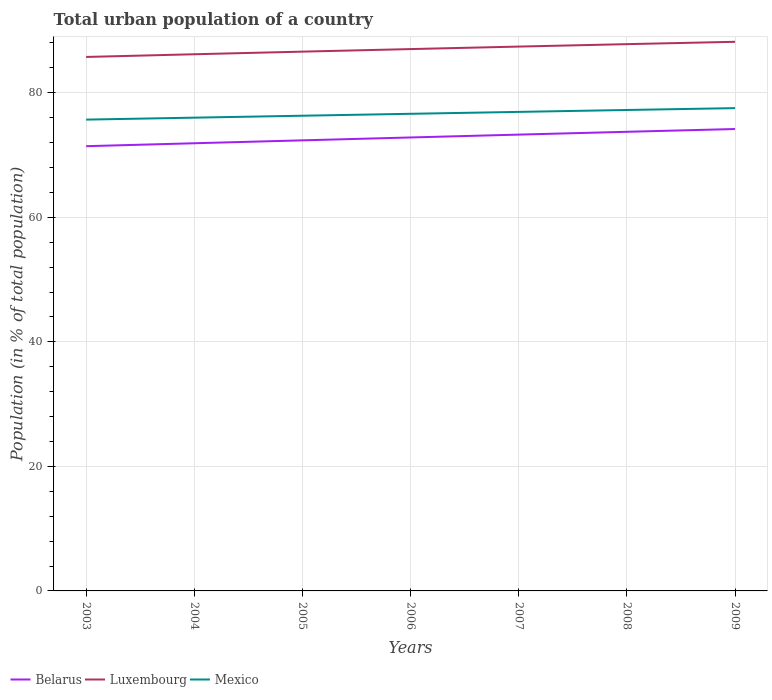Across all years, what is the maximum urban population in Luxembourg?
Offer a terse response. 85.74. What is the total urban population in Belarus in the graph?
Your answer should be very brief. -0.46. What is the difference between the highest and the second highest urban population in Belarus?
Provide a succinct answer. 2.76. What is the difference between the highest and the lowest urban population in Mexico?
Offer a very short reply. 4. Is the urban population in Mexico strictly greater than the urban population in Belarus over the years?
Keep it short and to the point. No. How many years are there in the graph?
Ensure brevity in your answer.  7. What is the difference between two consecutive major ticks on the Y-axis?
Your response must be concise. 20. Does the graph contain any zero values?
Your answer should be very brief. No. Does the graph contain grids?
Ensure brevity in your answer.  Yes. What is the title of the graph?
Provide a succinct answer. Total urban population of a country. Does "Bahrain" appear as one of the legend labels in the graph?
Offer a terse response. No. What is the label or title of the X-axis?
Ensure brevity in your answer.  Years. What is the label or title of the Y-axis?
Your response must be concise. Population (in % of total population). What is the Population (in % of total population) in Belarus in 2003?
Offer a terse response. 71.42. What is the Population (in % of total population) of Luxembourg in 2003?
Provide a succinct answer. 85.74. What is the Population (in % of total population) in Mexico in 2003?
Provide a succinct answer. 75.68. What is the Population (in % of total population) of Belarus in 2004?
Keep it short and to the point. 71.89. What is the Population (in % of total population) of Luxembourg in 2004?
Provide a succinct answer. 86.18. What is the Population (in % of total population) in Mexico in 2004?
Provide a short and direct response. 76. What is the Population (in % of total population) in Belarus in 2005?
Give a very brief answer. 72.35. What is the Population (in % of total population) in Luxembourg in 2005?
Your response must be concise. 86.6. What is the Population (in % of total population) in Mexico in 2005?
Give a very brief answer. 76.31. What is the Population (in % of total population) in Belarus in 2006?
Keep it short and to the point. 72.82. What is the Population (in % of total population) of Luxembourg in 2006?
Offer a very short reply. 87.01. What is the Population (in % of total population) in Mexico in 2006?
Give a very brief answer. 76.62. What is the Population (in % of total population) in Belarus in 2007?
Your answer should be compact. 73.27. What is the Population (in % of total population) of Luxembourg in 2007?
Give a very brief answer. 87.41. What is the Population (in % of total population) in Mexico in 2007?
Ensure brevity in your answer.  76.92. What is the Population (in % of total population) in Belarus in 2008?
Keep it short and to the point. 73.73. What is the Population (in % of total population) of Luxembourg in 2008?
Offer a very short reply. 87.8. What is the Population (in % of total population) of Mexico in 2008?
Keep it short and to the point. 77.23. What is the Population (in % of total population) in Belarus in 2009?
Your answer should be compact. 74.17. What is the Population (in % of total population) of Luxembourg in 2009?
Offer a terse response. 88.18. What is the Population (in % of total population) of Mexico in 2009?
Keep it short and to the point. 77.53. Across all years, what is the maximum Population (in % of total population) of Belarus?
Give a very brief answer. 74.17. Across all years, what is the maximum Population (in % of total population) of Luxembourg?
Make the answer very short. 88.18. Across all years, what is the maximum Population (in % of total population) of Mexico?
Give a very brief answer. 77.53. Across all years, what is the minimum Population (in % of total population) of Belarus?
Offer a terse response. 71.42. Across all years, what is the minimum Population (in % of total population) of Luxembourg?
Your answer should be very brief. 85.74. Across all years, what is the minimum Population (in % of total population) of Mexico?
Your answer should be compact. 75.68. What is the total Population (in % of total population) in Belarus in the graph?
Your response must be concise. 509.64. What is the total Population (in % of total population) of Luxembourg in the graph?
Make the answer very short. 608.91. What is the total Population (in % of total population) in Mexico in the graph?
Offer a terse response. 536.28. What is the difference between the Population (in % of total population) of Belarus in 2003 and that in 2004?
Offer a terse response. -0.47. What is the difference between the Population (in % of total population) in Luxembourg in 2003 and that in 2004?
Offer a very short reply. -0.43. What is the difference between the Population (in % of total population) in Mexico in 2003 and that in 2004?
Keep it short and to the point. -0.32. What is the difference between the Population (in % of total population) in Belarus in 2003 and that in 2005?
Offer a very short reply. -0.94. What is the difference between the Population (in % of total population) in Luxembourg in 2003 and that in 2005?
Provide a succinct answer. -0.85. What is the difference between the Population (in % of total population) in Mexico in 2003 and that in 2005?
Provide a succinct answer. -0.63. What is the difference between the Population (in % of total population) in Belarus in 2003 and that in 2006?
Provide a succinct answer. -1.4. What is the difference between the Population (in % of total population) in Luxembourg in 2003 and that in 2006?
Offer a very short reply. -1.27. What is the difference between the Population (in % of total population) in Mexico in 2003 and that in 2006?
Offer a very short reply. -0.94. What is the difference between the Population (in % of total population) of Belarus in 2003 and that in 2007?
Provide a short and direct response. -1.86. What is the difference between the Population (in % of total population) in Luxembourg in 2003 and that in 2007?
Offer a terse response. -1.67. What is the difference between the Population (in % of total population) in Mexico in 2003 and that in 2007?
Provide a succinct answer. -1.24. What is the difference between the Population (in % of total population) of Belarus in 2003 and that in 2008?
Offer a terse response. -2.31. What is the difference between the Population (in % of total population) of Luxembourg in 2003 and that in 2008?
Your answer should be compact. -2.06. What is the difference between the Population (in % of total population) of Mexico in 2003 and that in 2008?
Keep it short and to the point. -1.54. What is the difference between the Population (in % of total population) in Belarus in 2003 and that in 2009?
Provide a short and direct response. -2.76. What is the difference between the Population (in % of total population) in Luxembourg in 2003 and that in 2009?
Offer a terse response. -2.44. What is the difference between the Population (in % of total population) of Mexico in 2003 and that in 2009?
Give a very brief answer. -1.84. What is the difference between the Population (in % of total population) in Belarus in 2004 and that in 2005?
Ensure brevity in your answer.  -0.47. What is the difference between the Population (in % of total population) of Luxembourg in 2004 and that in 2005?
Provide a short and direct response. -0.42. What is the difference between the Population (in % of total population) in Mexico in 2004 and that in 2005?
Offer a terse response. -0.31. What is the difference between the Population (in % of total population) of Belarus in 2004 and that in 2006?
Give a very brief answer. -0.93. What is the difference between the Population (in % of total population) of Luxembourg in 2004 and that in 2006?
Provide a succinct answer. -0.83. What is the difference between the Population (in % of total population) in Mexico in 2004 and that in 2006?
Your answer should be compact. -0.62. What is the difference between the Population (in % of total population) in Belarus in 2004 and that in 2007?
Your response must be concise. -1.39. What is the difference between the Population (in % of total population) in Luxembourg in 2004 and that in 2007?
Provide a succinct answer. -1.23. What is the difference between the Population (in % of total population) of Mexico in 2004 and that in 2007?
Provide a succinct answer. -0.93. What is the difference between the Population (in % of total population) of Belarus in 2004 and that in 2008?
Give a very brief answer. -1.84. What is the difference between the Population (in % of total population) in Luxembourg in 2004 and that in 2008?
Your answer should be compact. -1.62. What is the difference between the Population (in % of total population) of Mexico in 2004 and that in 2008?
Make the answer very short. -1.23. What is the difference between the Population (in % of total population) in Belarus in 2004 and that in 2009?
Keep it short and to the point. -2.29. What is the difference between the Population (in % of total population) of Luxembourg in 2004 and that in 2009?
Make the answer very short. -2. What is the difference between the Population (in % of total population) of Mexico in 2004 and that in 2009?
Your answer should be compact. -1.53. What is the difference between the Population (in % of total population) of Belarus in 2005 and that in 2006?
Your answer should be very brief. -0.46. What is the difference between the Population (in % of total population) in Luxembourg in 2005 and that in 2006?
Your answer should be compact. -0.41. What is the difference between the Population (in % of total population) of Mexico in 2005 and that in 2006?
Your response must be concise. -0.31. What is the difference between the Population (in % of total population) of Belarus in 2005 and that in 2007?
Your answer should be very brief. -0.92. What is the difference between the Population (in % of total population) of Luxembourg in 2005 and that in 2007?
Give a very brief answer. -0.81. What is the difference between the Population (in % of total population) in Mexico in 2005 and that in 2007?
Offer a terse response. -0.61. What is the difference between the Population (in % of total population) of Belarus in 2005 and that in 2008?
Offer a terse response. -1.37. What is the difference between the Population (in % of total population) in Luxembourg in 2005 and that in 2008?
Make the answer very short. -1.2. What is the difference between the Population (in % of total population) in Mexico in 2005 and that in 2008?
Provide a short and direct response. -0.92. What is the difference between the Population (in % of total population) of Belarus in 2005 and that in 2009?
Make the answer very short. -1.82. What is the difference between the Population (in % of total population) in Luxembourg in 2005 and that in 2009?
Give a very brief answer. -1.58. What is the difference between the Population (in % of total population) of Mexico in 2005 and that in 2009?
Your answer should be compact. -1.22. What is the difference between the Population (in % of total population) of Belarus in 2006 and that in 2007?
Offer a very short reply. -0.46. What is the difference between the Population (in % of total population) of Luxembourg in 2006 and that in 2007?
Keep it short and to the point. -0.4. What is the difference between the Population (in % of total population) in Mexico in 2006 and that in 2007?
Give a very brief answer. -0.31. What is the difference between the Population (in % of total population) of Belarus in 2006 and that in 2008?
Your answer should be compact. -0.91. What is the difference between the Population (in % of total population) of Luxembourg in 2006 and that in 2008?
Provide a succinct answer. -0.79. What is the difference between the Population (in % of total population) of Mexico in 2006 and that in 2008?
Offer a very short reply. -0.61. What is the difference between the Population (in % of total population) of Belarus in 2006 and that in 2009?
Offer a very short reply. -1.36. What is the difference between the Population (in % of total population) of Luxembourg in 2006 and that in 2009?
Your answer should be very brief. -1.17. What is the difference between the Population (in % of total population) of Mexico in 2006 and that in 2009?
Offer a very short reply. -0.91. What is the difference between the Population (in % of total population) of Belarus in 2007 and that in 2008?
Give a very brief answer. -0.45. What is the difference between the Population (in % of total population) of Luxembourg in 2007 and that in 2008?
Your response must be concise. -0.39. What is the difference between the Population (in % of total population) of Mexico in 2007 and that in 2008?
Give a very brief answer. -0.3. What is the difference between the Population (in % of total population) of Belarus in 2007 and that in 2009?
Provide a short and direct response. -0.9. What is the difference between the Population (in % of total population) of Luxembourg in 2007 and that in 2009?
Keep it short and to the point. -0.77. What is the difference between the Population (in % of total population) in Mexico in 2007 and that in 2009?
Give a very brief answer. -0.6. What is the difference between the Population (in % of total population) of Belarus in 2008 and that in 2009?
Your response must be concise. -0.45. What is the difference between the Population (in % of total population) of Luxembourg in 2008 and that in 2009?
Give a very brief answer. -0.38. What is the difference between the Population (in % of total population) in Belarus in 2003 and the Population (in % of total population) in Luxembourg in 2004?
Keep it short and to the point. -14.76. What is the difference between the Population (in % of total population) in Belarus in 2003 and the Population (in % of total population) in Mexico in 2004?
Your response must be concise. -4.58. What is the difference between the Population (in % of total population) in Luxembourg in 2003 and the Population (in % of total population) in Mexico in 2004?
Provide a short and direct response. 9.75. What is the difference between the Population (in % of total population) in Belarus in 2003 and the Population (in % of total population) in Luxembourg in 2005?
Provide a succinct answer. -15.18. What is the difference between the Population (in % of total population) of Belarus in 2003 and the Population (in % of total population) of Mexico in 2005?
Make the answer very short. -4.89. What is the difference between the Population (in % of total population) in Luxembourg in 2003 and the Population (in % of total population) in Mexico in 2005?
Offer a terse response. 9.44. What is the difference between the Population (in % of total population) of Belarus in 2003 and the Population (in % of total population) of Luxembourg in 2006?
Make the answer very short. -15.59. What is the difference between the Population (in % of total population) in Belarus in 2003 and the Population (in % of total population) in Mexico in 2006?
Ensure brevity in your answer.  -5.2. What is the difference between the Population (in % of total population) of Luxembourg in 2003 and the Population (in % of total population) of Mexico in 2006?
Give a very brief answer. 9.13. What is the difference between the Population (in % of total population) in Belarus in 2003 and the Population (in % of total population) in Luxembourg in 2007?
Provide a short and direct response. -15.99. What is the difference between the Population (in % of total population) of Belarus in 2003 and the Population (in % of total population) of Mexico in 2007?
Provide a succinct answer. -5.51. What is the difference between the Population (in % of total population) in Luxembourg in 2003 and the Population (in % of total population) in Mexico in 2007?
Make the answer very short. 8.82. What is the difference between the Population (in % of total population) in Belarus in 2003 and the Population (in % of total population) in Luxembourg in 2008?
Offer a terse response. -16.39. What is the difference between the Population (in % of total population) in Belarus in 2003 and the Population (in % of total population) in Mexico in 2008?
Provide a short and direct response. -5.81. What is the difference between the Population (in % of total population) of Luxembourg in 2003 and the Population (in % of total population) of Mexico in 2008?
Offer a very short reply. 8.52. What is the difference between the Population (in % of total population) of Belarus in 2003 and the Population (in % of total population) of Luxembourg in 2009?
Your response must be concise. -16.76. What is the difference between the Population (in % of total population) of Belarus in 2003 and the Population (in % of total population) of Mexico in 2009?
Provide a succinct answer. -6.11. What is the difference between the Population (in % of total population) of Luxembourg in 2003 and the Population (in % of total population) of Mexico in 2009?
Give a very brief answer. 8.22. What is the difference between the Population (in % of total population) in Belarus in 2004 and the Population (in % of total population) in Luxembourg in 2005?
Give a very brief answer. -14.71. What is the difference between the Population (in % of total population) of Belarus in 2004 and the Population (in % of total population) of Mexico in 2005?
Your answer should be compact. -4.42. What is the difference between the Population (in % of total population) in Luxembourg in 2004 and the Population (in % of total population) in Mexico in 2005?
Ensure brevity in your answer.  9.87. What is the difference between the Population (in % of total population) of Belarus in 2004 and the Population (in % of total population) of Luxembourg in 2006?
Your answer should be very brief. -15.12. What is the difference between the Population (in % of total population) in Belarus in 2004 and the Population (in % of total population) in Mexico in 2006?
Provide a succinct answer. -4.73. What is the difference between the Population (in % of total population) of Luxembourg in 2004 and the Population (in % of total population) of Mexico in 2006?
Offer a terse response. 9.56. What is the difference between the Population (in % of total population) in Belarus in 2004 and the Population (in % of total population) in Luxembourg in 2007?
Ensure brevity in your answer.  -15.52. What is the difference between the Population (in % of total population) in Belarus in 2004 and the Population (in % of total population) in Mexico in 2007?
Your answer should be compact. -5.04. What is the difference between the Population (in % of total population) of Luxembourg in 2004 and the Population (in % of total population) of Mexico in 2007?
Offer a terse response. 9.25. What is the difference between the Population (in % of total population) in Belarus in 2004 and the Population (in % of total population) in Luxembourg in 2008?
Offer a very short reply. -15.91. What is the difference between the Population (in % of total population) in Belarus in 2004 and the Population (in % of total population) in Mexico in 2008?
Your answer should be compact. -5.34. What is the difference between the Population (in % of total population) in Luxembourg in 2004 and the Population (in % of total population) in Mexico in 2008?
Offer a terse response. 8.95. What is the difference between the Population (in % of total population) of Belarus in 2004 and the Population (in % of total population) of Luxembourg in 2009?
Ensure brevity in your answer.  -16.29. What is the difference between the Population (in % of total population) of Belarus in 2004 and the Population (in % of total population) of Mexico in 2009?
Your response must be concise. -5.64. What is the difference between the Population (in % of total population) in Luxembourg in 2004 and the Population (in % of total population) in Mexico in 2009?
Give a very brief answer. 8.65. What is the difference between the Population (in % of total population) in Belarus in 2005 and the Population (in % of total population) in Luxembourg in 2006?
Your answer should be very brief. -14.65. What is the difference between the Population (in % of total population) of Belarus in 2005 and the Population (in % of total population) of Mexico in 2006?
Your answer should be compact. -4.26. What is the difference between the Population (in % of total population) in Luxembourg in 2005 and the Population (in % of total population) in Mexico in 2006?
Your answer should be compact. 9.98. What is the difference between the Population (in % of total population) in Belarus in 2005 and the Population (in % of total population) in Luxembourg in 2007?
Provide a short and direct response. -15.05. What is the difference between the Population (in % of total population) of Belarus in 2005 and the Population (in % of total population) of Mexico in 2007?
Your answer should be very brief. -4.57. What is the difference between the Population (in % of total population) of Luxembourg in 2005 and the Population (in % of total population) of Mexico in 2007?
Give a very brief answer. 9.68. What is the difference between the Population (in % of total population) of Belarus in 2005 and the Population (in % of total population) of Luxembourg in 2008?
Your answer should be compact. -15.45. What is the difference between the Population (in % of total population) in Belarus in 2005 and the Population (in % of total population) in Mexico in 2008?
Your answer should be very brief. -4.87. What is the difference between the Population (in % of total population) in Luxembourg in 2005 and the Population (in % of total population) in Mexico in 2008?
Provide a succinct answer. 9.37. What is the difference between the Population (in % of total population) of Belarus in 2005 and the Population (in % of total population) of Luxembourg in 2009?
Your response must be concise. -15.82. What is the difference between the Population (in % of total population) of Belarus in 2005 and the Population (in % of total population) of Mexico in 2009?
Keep it short and to the point. -5.17. What is the difference between the Population (in % of total population) of Luxembourg in 2005 and the Population (in % of total population) of Mexico in 2009?
Ensure brevity in your answer.  9.07. What is the difference between the Population (in % of total population) of Belarus in 2006 and the Population (in % of total population) of Luxembourg in 2007?
Your answer should be very brief. -14.59. What is the difference between the Population (in % of total population) in Belarus in 2006 and the Population (in % of total population) in Mexico in 2007?
Make the answer very short. -4.11. What is the difference between the Population (in % of total population) of Luxembourg in 2006 and the Population (in % of total population) of Mexico in 2007?
Your answer should be compact. 10.09. What is the difference between the Population (in % of total population) of Belarus in 2006 and the Population (in % of total population) of Luxembourg in 2008?
Your response must be concise. -14.98. What is the difference between the Population (in % of total population) in Belarus in 2006 and the Population (in % of total population) in Mexico in 2008?
Keep it short and to the point. -4.41. What is the difference between the Population (in % of total population) of Luxembourg in 2006 and the Population (in % of total population) of Mexico in 2008?
Keep it short and to the point. 9.78. What is the difference between the Population (in % of total population) of Belarus in 2006 and the Population (in % of total population) of Luxembourg in 2009?
Your answer should be compact. -15.36. What is the difference between the Population (in % of total population) in Belarus in 2006 and the Population (in % of total population) in Mexico in 2009?
Provide a succinct answer. -4.71. What is the difference between the Population (in % of total population) of Luxembourg in 2006 and the Population (in % of total population) of Mexico in 2009?
Give a very brief answer. 9.48. What is the difference between the Population (in % of total population) of Belarus in 2007 and the Population (in % of total population) of Luxembourg in 2008?
Ensure brevity in your answer.  -14.53. What is the difference between the Population (in % of total population) of Belarus in 2007 and the Population (in % of total population) of Mexico in 2008?
Provide a short and direct response. -3.95. What is the difference between the Population (in % of total population) of Luxembourg in 2007 and the Population (in % of total population) of Mexico in 2008?
Offer a very short reply. 10.18. What is the difference between the Population (in % of total population) of Belarus in 2007 and the Population (in % of total population) of Luxembourg in 2009?
Ensure brevity in your answer.  -14.9. What is the difference between the Population (in % of total population) in Belarus in 2007 and the Population (in % of total population) in Mexico in 2009?
Give a very brief answer. -4.25. What is the difference between the Population (in % of total population) of Luxembourg in 2007 and the Population (in % of total population) of Mexico in 2009?
Your answer should be compact. 9.88. What is the difference between the Population (in % of total population) of Belarus in 2008 and the Population (in % of total population) of Luxembourg in 2009?
Ensure brevity in your answer.  -14.45. What is the difference between the Population (in % of total population) of Belarus in 2008 and the Population (in % of total population) of Mexico in 2009?
Your answer should be compact. -3.8. What is the difference between the Population (in % of total population) in Luxembourg in 2008 and the Population (in % of total population) in Mexico in 2009?
Your answer should be very brief. 10.27. What is the average Population (in % of total population) of Belarus per year?
Offer a very short reply. 72.81. What is the average Population (in % of total population) in Luxembourg per year?
Make the answer very short. 86.99. What is the average Population (in % of total population) in Mexico per year?
Ensure brevity in your answer.  76.61. In the year 2003, what is the difference between the Population (in % of total population) in Belarus and Population (in % of total population) in Luxembourg?
Give a very brief answer. -14.33. In the year 2003, what is the difference between the Population (in % of total population) in Belarus and Population (in % of total population) in Mexico?
Your answer should be compact. -4.27. In the year 2003, what is the difference between the Population (in % of total population) of Luxembourg and Population (in % of total population) of Mexico?
Give a very brief answer. 10.06. In the year 2004, what is the difference between the Population (in % of total population) in Belarus and Population (in % of total population) in Luxembourg?
Provide a succinct answer. -14.29. In the year 2004, what is the difference between the Population (in % of total population) in Belarus and Population (in % of total population) in Mexico?
Offer a terse response. -4.11. In the year 2004, what is the difference between the Population (in % of total population) of Luxembourg and Population (in % of total population) of Mexico?
Make the answer very short. 10.18. In the year 2005, what is the difference between the Population (in % of total population) in Belarus and Population (in % of total population) in Luxembourg?
Offer a very short reply. -14.24. In the year 2005, what is the difference between the Population (in % of total population) in Belarus and Population (in % of total population) in Mexico?
Provide a short and direct response. -3.95. In the year 2005, what is the difference between the Population (in % of total population) in Luxembourg and Population (in % of total population) in Mexico?
Your answer should be very brief. 10.29. In the year 2006, what is the difference between the Population (in % of total population) in Belarus and Population (in % of total population) in Luxembourg?
Keep it short and to the point. -14.19. In the year 2006, what is the difference between the Population (in % of total population) of Belarus and Population (in % of total population) of Mexico?
Give a very brief answer. -3.8. In the year 2006, what is the difference between the Population (in % of total population) of Luxembourg and Population (in % of total population) of Mexico?
Ensure brevity in your answer.  10.39. In the year 2007, what is the difference between the Population (in % of total population) of Belarus and Population (in % of total population) of Luxembourg?
Keep it short and to the point. -14.14. In the year 2007, what is the difference between the Population (in % of total population) of Belarus and Population (in % of total population) of Mexico?
Your response must be concise. -3.65. In the year 2007, what is the difference between the Population (in % of total population) of Luxembourg and Population (in % of total population) of Mexico?
Provide a succinct answer. 10.49. In the year 2008, what is the difference between the Population (in % of total population) in Belarus and Population (in % of total population) in Luxembourg?
Ensure brevity in your answer.  -14.07. In the year 2008, what is the difference between the Population (in % of total population) of Belarus and Population (in % of total population) of Mexico?
Ensure brevity in your answer.  -3.5. In the year 2008, what is the difference between the Population (in % of total population) in Luxembourg and Population (in % of total population) in Mexico?
Provide a succinct answer. 10.57. In the year 2009, what is the difference between the Population (in % of total population) in Belarus and Population (in % of total population) in Luxembourg?
Offer a terse response. -14.01. In the year 2009, what is the difference between the Population (in % of total population) in Belarus and Population (in % of total population) in Mexico?
Your response must be concise. -3.35. In the year 2009, what is the difference between the Population (in % of total population) in Luxembourg and Population (in % of total population) in Mexico?
Ensure brevity in your answer.  10.65. What is the ratio of the Population (in % of total population) of Belarus in 2003 to that in 2004?
Keep it short and to the point. 0.99. What is the ratio of the Population (in % of total population) in Luxembourg in 2003 to that in 2004?
Offer a terse response. 0.99. What is the ratio of the Population (in % of total population) of Mexico in 2003 to that in 2004?
Give a very brief answer. 1. What is the ratio of the Population (in % of total population) in Luxembourg in 2003 to that in 2005?
Ensure brevity in your answer.  0.99. What is the ratio of the Population (in % of total population) of Belarus in 2003 to that in 2006?
Offer a very short reply. 0.98. What is the ratio of the Population (in % of total population) in Luxembourg in 2003 to that in 2006?
Provide a succinct answer. 0.99. What is the ratio of the Population (in % of total population) in Belarus in 2003 to that in 2007?
Keep it short and to the point. 0.97. What is the ratio of the Population (in % of total population) in Luxembourg in 2003 to that in 2007?
Keep it short and to the point. 0.98. What is the ratio of the Population (in % of total population) of Mexico in 2003 to that in 2007?
Offer a very short reply. 0.98. What is the ratio of the Population (in % of total population) of Belarus in 2003 to that in 2008?
Your response must be concise. 0.97. What is the ratio of the Population (in % of total population) in Luxembourg in 2003 to that in 2008?
Make the answer very short. 0.98. What is the ratio of the Population (in % of total population) in Mexico in 2003 to that in 2008?
Provide a succinct answer. 0.98. What is the ratio of the Population (in % of total population) of Belarus in 2003 to that in 2009?
Keep it short and to the point. 0.96. What is the ratio of the Population (in % of total population) in Luxembourg in 2003 to that in 2009?
Offer a terse response. 0.97. What is the ratio of the Population (in % of total population) of Mexico in 2003 to that in 2009?
Your response must be concise. 0.98. What is the ratio of the Population (in % of total population) in Belarus in 2004 to that in 2005?
Provide a succinct answer. 0.99. What is the ratio of the Population (in % of total population) in Luxembourg in 2004 to that in 2005?
Offer a terse response. 1. What is the ratio of the Population (in % of total population) of Mexico in 2004 to that in 2005?
Your answer should be very brief. 1. What is the ratio of the Population (in % of total population) in Belarus in 2004 to that in 2006?
Provide a succinct answer. 0.99. What is the ratio of the Population (in % of total population) of Luxembourg in 2004 to that in 2006?
Give a very brief answer. 0.99. What is the ratio of the Population (in % of total population) in Mexico in 2004 to that in 2006?
Give a very brief answer. 0.99. What is the ratio of the Population (in % of total population) of Belarus in 2004 to that in 2007?
Keep it short and to the point. 0.98. What is the ratio of the Population (in % of total population) of Luxembourg in 2004 to that in 2007?
Your response must be concise. 0.99. What is the ratio of the Population (in % of total population) of Mexico in 2004 to that in 2007?
Provide a short and direct response. 0.99. What is the ratio of the Population (in % of total population) of Belarus in 2004 to that in 2008?
Your response must be concise. 0.98. What is the ratio of the Population (in % of total population) in Luxembourg in 2004 to that in 2008?
Provide a succinct answer. 0.98. What is the ratio of the Population (in % of total population) in Mexico in 2004 to that in 2008?
Offer a terse response. 0.98. What is the ratio of the Population (in % of total population) in Belarus in 2004 to that in 2009?
Your answer should be compact. 0.97. What is the ratio of the Population (in % of total population) of Luxembourg in 2004 to that in 2009?
Keep it short and to the point. 0.98. What is the ratio of the Population (in % of total population) in Mexico in 2004 to that in 2009?
Provide a short and direct response. 0.98. What is the ratio of the Population (in % of total population) in Belarus in 2005 to that in 2006?
Offer a very short reply. 0.99. What is the ratio of the Population (in % of total population) in Mexico in 2005 to that in 2006?
Provide a short and direct response. 1. What is the ratio of the Population (in % of total population) of Belarus in 2005 to that in 2007?
Make the answer very short. 0.99. What is the ratio of the Population (in % of total population) of Belarus in 2005 to that in 2008?
Provide a short and direct response. 0.98. What is the ratio of the Population (in % of total population) of Luxembourg in 2005 to that in 2008?
Your answer should be compact. 0.99. What is the ratio of the Population (in % of total population) of Mexico in 2005 to that in 2008?
Provide a succinct answer. 0.99. What is the ratio of the Population (in % of total population) of Belarus in 2005 to that in 2009?
Your answer should be compact. 0.98. What is the ratio of the Population (in % of total population) of Luxembourg in 2005 to that in 2009?
Your answer should be compact. 0.98. What is the ratio of the Population (in % of total population) in Mexico in 2005 to that in 2009?
Offer a very short reply. 0.98. What is the ratio of the Population (in % of total population) of Luxembourg in 2006 to that in 2007?
Provide a succinct answer. 1. What is the ratio of the Population (in % of total population) in Mexico in 2006 to that in 2007?
Provide a short and direct response. 1. What is the ratio of the Population (in % of total population) in Belarus in 2006 to that in 2009?
Give a very brief answer. 0.98. What is the ratio of the Population (in % of total population) in Luxembourg in 2006 to that in 2009?
Offer a terse response. 0.99. What is the ratio of the Population (in % of total population) of Mexico in 2006 to that in 2009?
Provide a short and direct response. 0.99. What is the ratio of the Population (in % of total population) in Belarus in 2007 to that in 2008?
Ensure brevity in your answer.  0.99. What is the ratio of the Population (in % of total population) in Belarus in 2007 to that in 2009?
Your response must be concise. 0.99. What is the ratio of the Population (in % of total population) of Luxembourg in 2007 to that in 2009?
Offer a terse response. 0.99. What is the ratio of the Population (in % of total population) of Mexico in 2007 to that in 2009?
Provide a succinct answer. 0.99. What is the ratio of the Population (in % of total population) of Luxembourg in 2008 to that in 2009?
Make the answer very short. 1. What is the difference between the highest and the second highest Population (in % of total population) in Belarus?
Ensure brevity in your answer.  0.45. What is the difference between the highest and the second highest Population (in % of total population) of Luxembourg?
Keep it short and to the point. 0.38. What is the difference between the highest and the lowest Population (in % of total population) in Belarus?
Provide a succinct answer. 2.76. What is the difference between the highest and the lowest Population (in % of total population) of Luxembourg?
Your answer should be compact. 2.44. What is the difference between the highest and the lowest Population (in % of total population) of Mexico?
Your answer should be very brief. 1.84. 